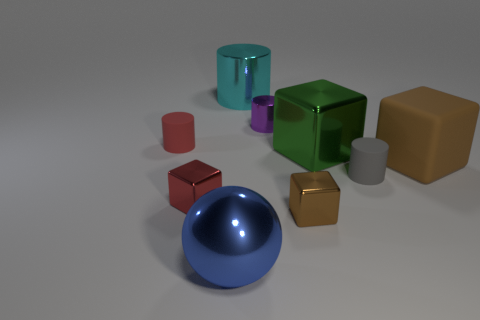Is the material of the big cylinder the same as the big blue sphere?
Provide a short and direct response. Yes. There is a tiny rubber object to the left of the large metallic object in front of the large green metal thing; what number of red rubber cylinders are to the left of it?
Keep it short and to the point. 0. The big object that is on the right side of the large green metallic cube has what shape?
Make the answer very short. Cube. How many other things are there of the same material as the big blue sphere?
Offer a terse response. 5. Is the color of the large rubber thing the same as the tiny metal cylinder?
Provide a succinct answer. No. Are there fewer small gray cylinders that are in front of the gray rubber cylinder than small red metallic blocks that are behind the cyan metallic thing?
Your answer should be very brief. No. The big metal thing that is the same shape as the brown matte thing is what color?
Make the answer very short. Green. There is a cylinder on the left side of the cyan cylinder; does it have the same size as the tiny red metallic cube?
Make the answer very short. Yes. Is the number of big brown matte cubes behind the large shiny block less than the number of blocks?
Offer a very short reply. Yes. Are there any other things that are the same size as the green thing?
Keep it short and to the point. Yes. 